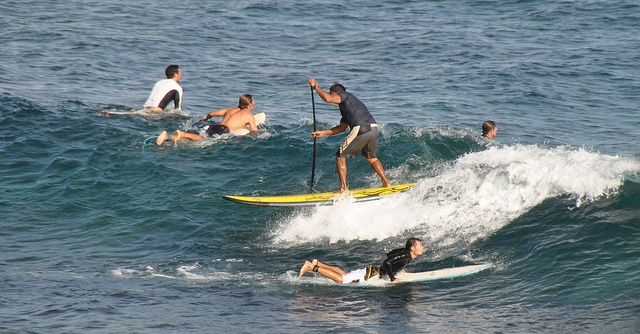Describe the objects in this image and their specific colors. I can see people in gray, black, salmon, and maroon tones, surfboard in gray, gold, and lightgray tones, people in gray, black, white, and tan tones, people in gray, salmon, tan, and black tones, and surfboard in gray, beige, darkgray, and purple tones in this image. 